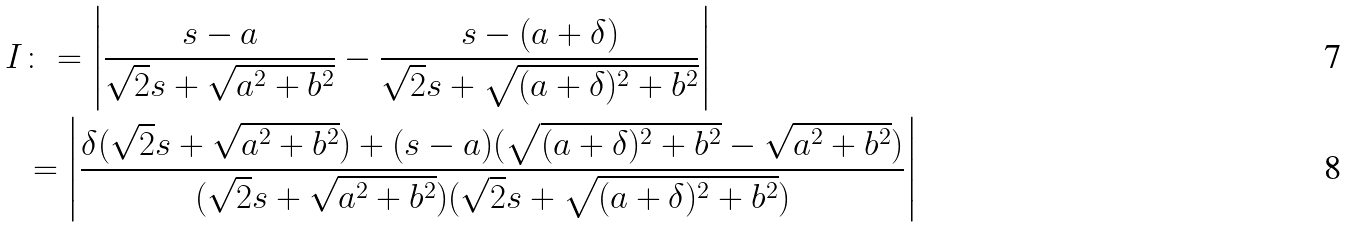<formula> <loc_0><loc_0><loc_500><loc_500>I & \colon = \left | \frac { s - a } { \sqrt { 2 } s + \sqrt { a ^ { 2 } + b ^ { 2 } } } - \frac { s - ( a + \delta ) } { \sqrt { 2 } s + \sqrt { ( a + \delta ) ^ { 2 } + b ^ { 2 } } } \right | \\ & = \left | \frac { \delta ( \sqrt { 2 } s + \sqrt { a ^ { 2 } + b ^ { 2 } } ) + ( s - a ) ( \sqrt { ( a + \delta ) ^ { 2 } + b ^ { 2 } } - \sqrt { a ^ { 2 } + b ^ { 2 } } ) } { ( \sqrt { 2 } s + \sqrt { a ^ { 2 } + b ^ { 2 } } ) ( \sqrt { 2 } s + \sqrt { ( a + \delta ) ^ { 2 } + b ^ { 2 } } ) } \right |</formula> 